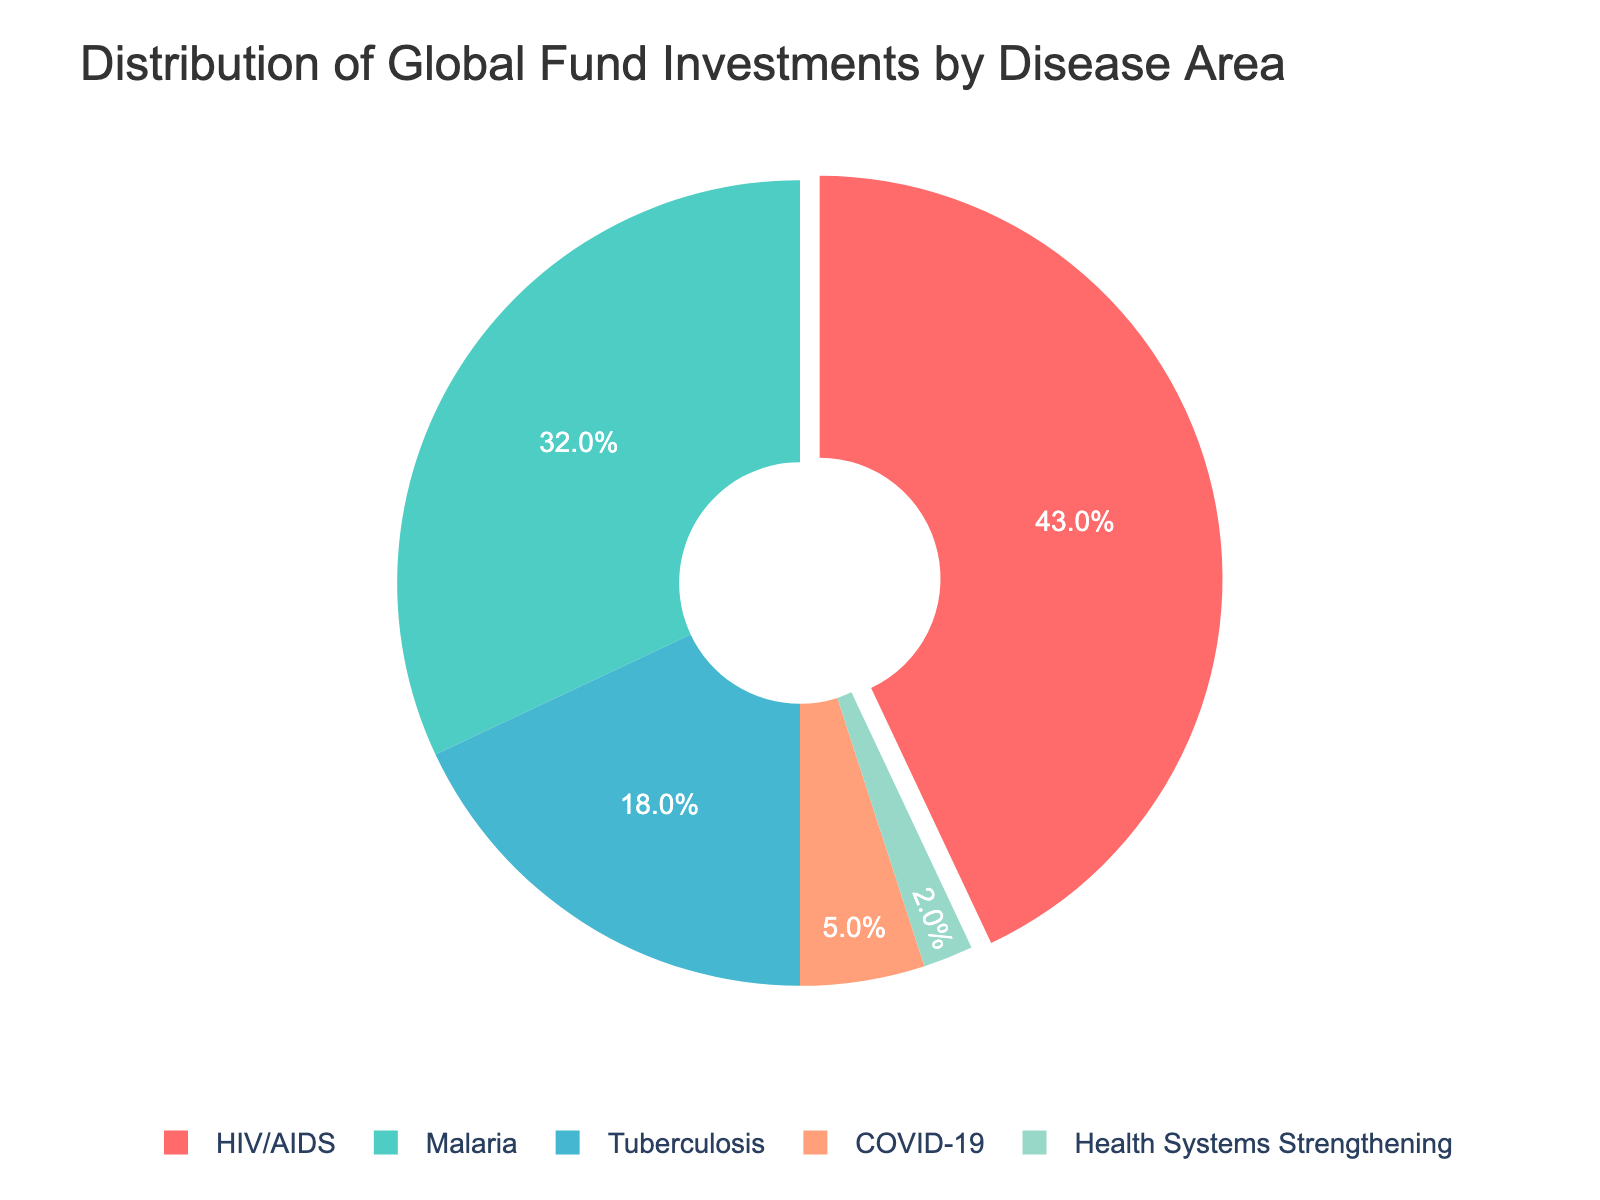What is the most-funded disease area according to the chart? The most-funded disease area is the one with the largest slice of the pie chart. In this case, it is HIV/AIDS with 43%.
Answer: HIV/AIDS Which two disease areas combined receive more than half of the total investment? To determine this, add the percentages of the top two slices. HIV/AIDS (43%) and Malaria (32%) together make 75%, which is more than half.
Answer: HIV/AIDS and Malaria How much more is invested in Tuberculosis than in Health Systems Strengthening? Subtract the percentage for Health Systems Strengthening from Tuberculosis. Tuberculosis has 18%, and Health Systems Strengthening has 2%, so the difference is 16%.
Answer: 16% What is the combined investment percentage for diseases not directly related to infections (COVID-19 and Health Systems Strengthening)? Sum the percentages for COVID-19 and Health Systems Strengthening: 5% + 2% = 7%.
Answer: 7% Which color represents Malaria in the chart and what is the investment percentage? Identify the color associated with Malaria. In the given color palette, it is the third color, a shade of blue, and its slice corresponds to 32%.
Answer: Blue, 32% What is the relative investment difference between the largest and smallest funded areas? Subtract the smallest slice (Health Systems Strengthening, 2%) from the largest slice (HIV/AIDS, 43%). The difference is 41%.
Answer: 41% Is the investment in Tuberculosis greater than the investment in COVID-19 and Health Systems Strengthening combined? Compare the percentage of Tuberculosis (18%) with the sum of COVID-19 (5%) and Health Systems Strengthening (2%), which is 7%. Since 18% is greater than 7%, Tuberculosis has a larger investment.
Answer: Yes How does the investment in Malaria compare to the combined investment of Tuberculosis and Health Systems Strengthening? Add the percentages of Tuberculosis (18%) and Health Systems Strengthening (2%) to get 20%. Compare this to Malaria's 32%. Malaria receives a larger percentage.
Answer: Malaria receives more What fraction of the total investment is allocated to HIV/AIDS and Tuberculosis combined? Sum the percentages for HIV/AIDS (43%) and Tuberculosis (18%), which gives 61%.
Answer: 61% What is the range of the investment percentages across all disease areas? The range is the difference between the maximum and minimum percentages. The highest is HIV/AIDS with 43% and the lowest is Health Systems Strengthening with 2%, so the range is 41%.
Answer: 41% 